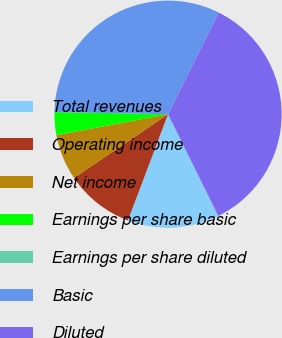Convert chart. <chart><loc_0><loc_0><loc_500><loc_500><pie_chart><fcel>Total revenues<fcel>Operating income<fcel>Net income<fcel>Earnings per share basic<fcel>Earnings per share diluted<fcel>Basic<fcel>Diluted<nl><fcel>13.04%<fcel>9.78%<fcel>6.52%<fcel>3.26%<fcel>0.0%<fcel>32.07%<fcel>35.33%<nl></chart> 